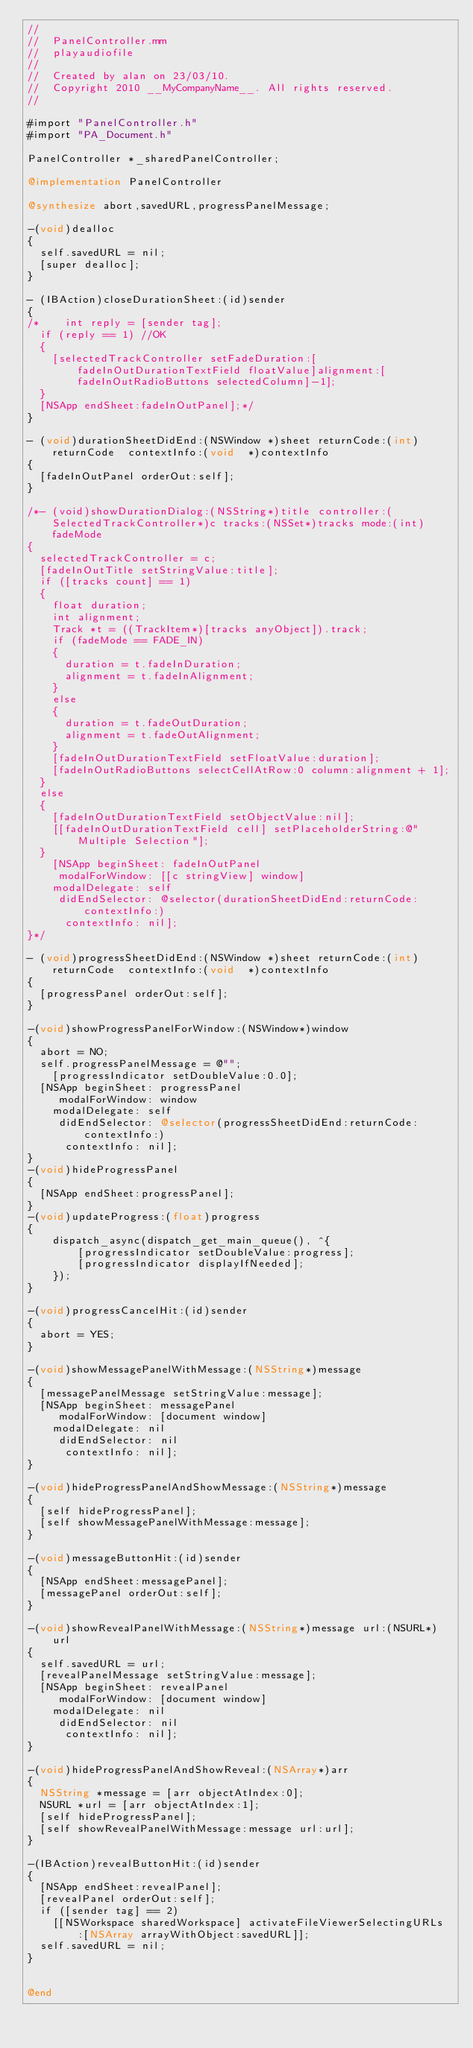<code> <loc_0><loc_0><loc_500><loc_500><_ObjectiveC_>//
//  PanelController.mm
//  playaudiofile
//
//  Created by alan on 23/03/10.
//  Copyright 2010 __MyCompanyName__. All rights reserved.
//

#import "PanelController.h"
#import "PA_Document.h"

PanelController *_sharedPanelController;

@implementation PanelController

@synthesize abort,savedURL,progressPanelMessage;

-(void)dealloc
{
	self.savedURL = nil;
	[super dealloc];
}

- (IBAction)closeDurationSheet:(id)sender
{
/*    int reply = [sender tag];
	if (reply == 1) //OK
	{
		[selectedTrackController setFadeDuration:[fadeInOutDurationTextField floatValue]alignment:[fadeInOutRadioButtons selectedColumn]-1];
	}
	[NSApp endSheet:fadeInOutPanel];*/
}

- (void)durationSheetDidEnd:(NSWindow *)sheet returnCode:(int)returnCode  contextInfo:(void  *)contextInfo
{
	[fadeInOutPanel orderOut:self];
}

/*- (void)showDurationDialog:(NSString*)title controller:(SelectedTrackController*)c tracks:(NSSet*)tracks mode:(int)fadeMode
{
	selectedTrackController = c;
	[fadeInOutTitle setStringValue:title];
	if ([tracks count] == 1)
	{
		float duration;
		int alignment;
		Track *t = ((TrackItem*)[tracks anyObject]).track;
		if (fadeMode == FADE_IN)
		{
			duration = t.fadeInDuration;
			alignment = t.fadeInAlignment;
		}
		else
		{
			duration = t.fadeOutDuration;
			alignment = t.fadeOutAlignment;
		}
		[fadeInOutDurationTextField setFloatValue:duration];
		[fadeInOutRadioButtons selectCellAtRow:0 column:alignment + 1];
	}
	else
	{
		[fadeInOutDurationTextField setObjectValue:nil];
		[[fadeInOutDurationTextField cell] setPlaceholderString:@"Multiple Selection"];
	}
    [NSApp beginSheet: fadeInOutPanel
	   modalForWindow: [[c stringView] window]
		modalDelegate: self
	   didEndSelector: @selector(durationSheetDidEnd:returnCode:contextInfo:)
		  contextInfo: nil];
}*/

- (void)progressSheetDidEnd:(NSWindow *)sheet returnCode:(int)returnCode  contextInfo:(void  *)contextInfo
{
	[progressPanel orderOut:self];
}

-(void)showProgressPanelForWindow:(NSWindow*)window
{
	abort = NO;
	self.progressPanelMessage = @"";
    [progressIndicator setDoubleValue:0.0];
	[NSApp beginSheet: progressPanel
	   modalForWindow: window
		modalDelegate: self
	   didEndSelector: @selector(progressSheetDidEnd:returnCode:contextInfo:)
		  contextInfo: nil];
}
-(void)hideProgressPanel
{
	[NSApp endSheet:progressPanel];
}
-(void)updateProgress:(float)progress
{
    dispatch_async(dispatch_get_main_queue(), ^{
        [progressIndicator setDoubleValue:progress];
        [progressIndicator displayIfNeeded];
    });
}

-(void)progressCancelHit:(id)sender
{
	abort = YES;
}

-(void)showMessagePanelWithMessage:(NSString*)message
{
	[messagePanelMessage setStringValue:message];
	[NSApp beginSheet: messagePanel
	   modalForWindow: [document window]
		modalDelegate: nil
	   didEndSelector: nil
		  contextInfo: nil];
}

-(void)hideProgressPanelAndShowMessage:(NSString*)message
{
	[self hideProgressPanel];
	[self showMessagePanelWithMessage:message];
}

-(void)messageButtonHit:(id)sender
{
	[NSApp endSheet:messagePanel];
	[messagePanel orderOut:self];
}

-(void)showRevealPanelWithMessage:(NSString*)message url:(NSURL*)url
{
	self.savedURL = url;
	[revealPanelMessage setStringValue:message];
	[NSApp beginSheet: revealPanel
	   modalForWindow: [document window]
		modalDelegate: nil
	   didEndSelector: nil
		  contextInfo: nil];
}

-(void)hideProgressPanelAndShowReveal:(NSArray*)arr
{
	NSString *message = [arr objectAtIndex:0];
	NSURL *url = [arr objectAtIndex:1];
	[self hideProgressPanel];
	[self showRevealPanelWithMessage:message url:url];
}

-(IBAction)revealButtonHit:(id)sender
{
	[NSApp endSheet:revealPanel];
	[revealPanel orderOut:self];
	if ([sender tag] == 2)
		[[NSWorkspace sharedWorkspace] activateFileViewerSelectingURLs:[NSArray arrayWithObject:savedURL]];
	self.savedURL = nil;
}


@end
</code> 